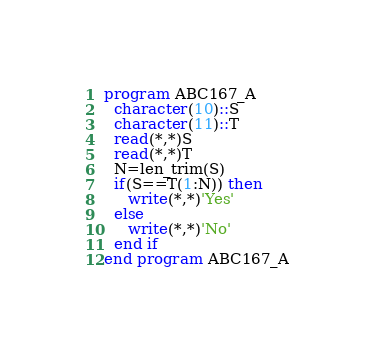Convert code to text. <code><loc_0><loc_0><loc_500><loc_500><_FORTRAN_>program ABC167_A
  character(10)::S
  character(11)::T
  read(*,*)S
  read(*,*)T
  N=len_trim(S)
  if(S==T(1:N)) then
     write(*,*)'Yes'
  else
     write(*,*)'No'
  end if
end program ABC167_A</code> 